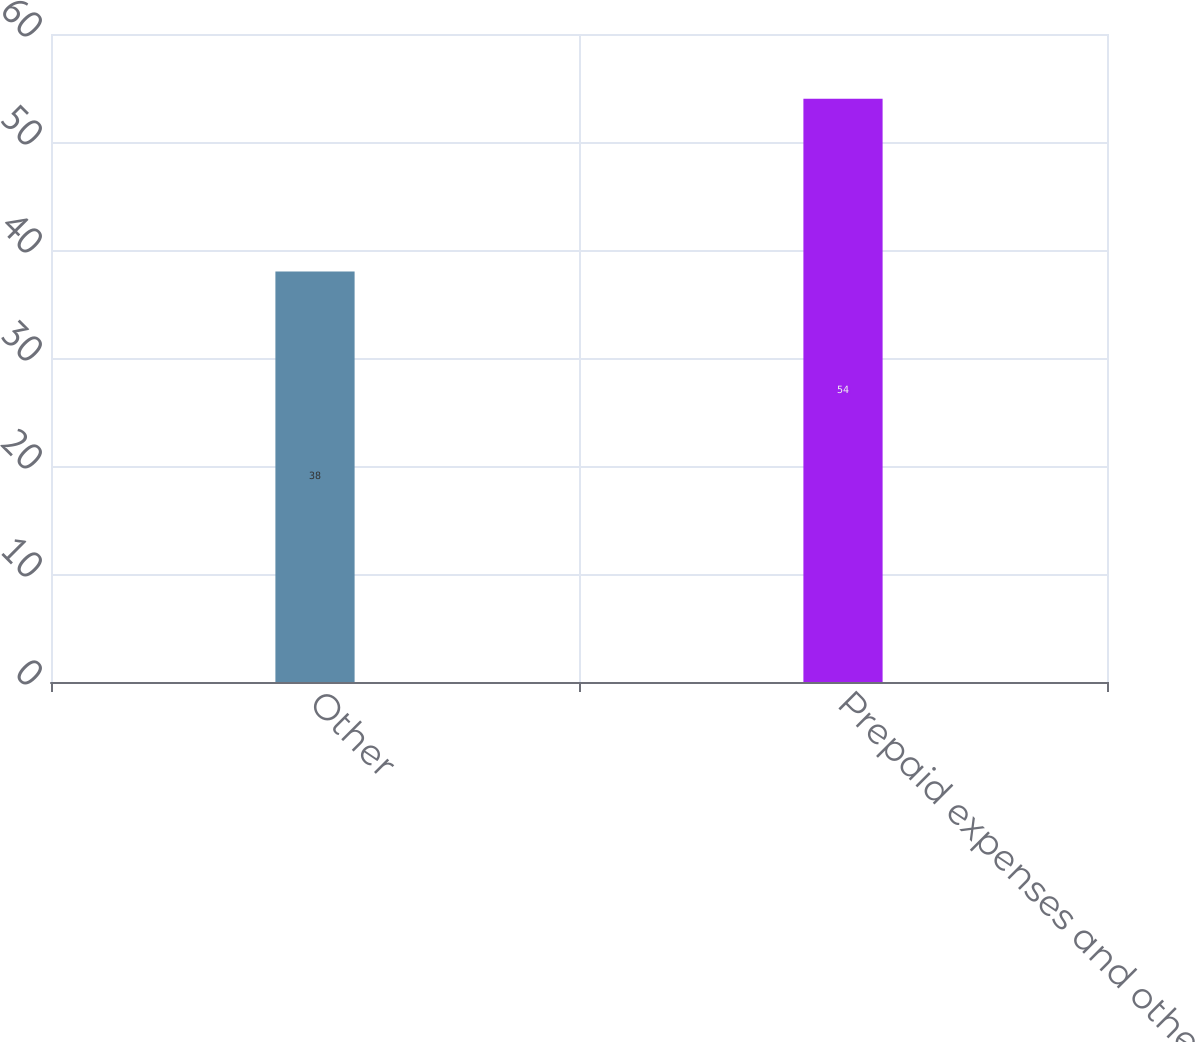Convert chart. <chart><loc_0><loc_0><loc_500><loc_500><bar_chart><fcel>Other<fcel>Prepaid expenses and other<nl><fcel>38<fcel>54<nl></chart> 